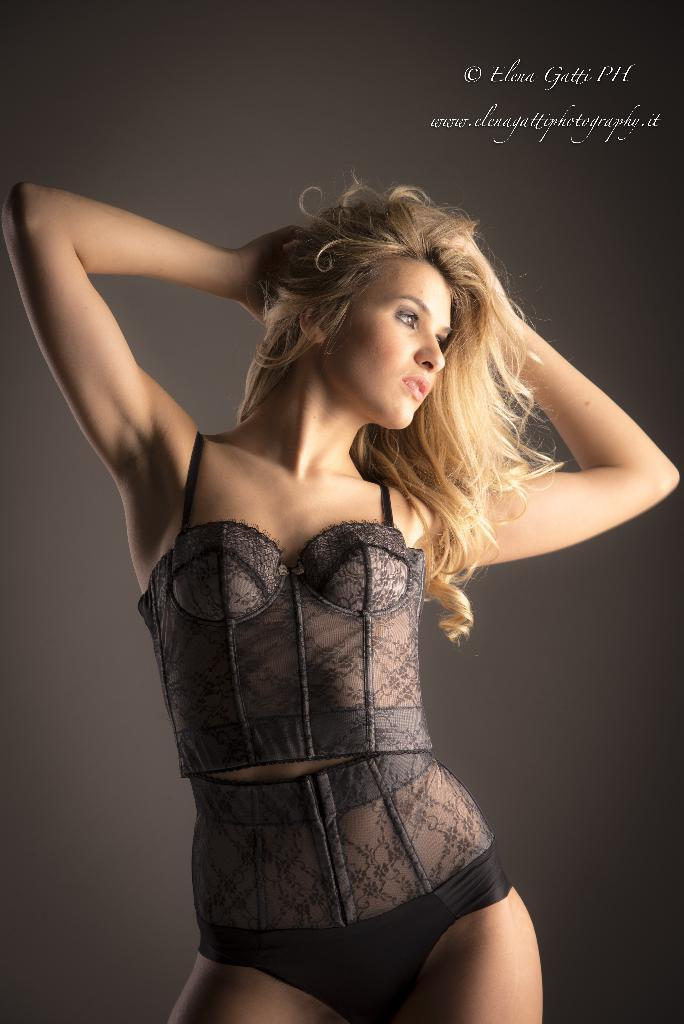What is the main subject of the image? The main subject of the image is a lady. What is the lady doing in the image? The lady is standing in the image. What is the lady wearing in the image? The lady is wearing a black dress in the image. Can you tell me how many horses are present in the image? There are no horses present in the image; it features a lady standing and wearing a black dress. What type of weather is depicted in the image? The image does not depict any weather conditions, as it focuses on the lady and her attire. 